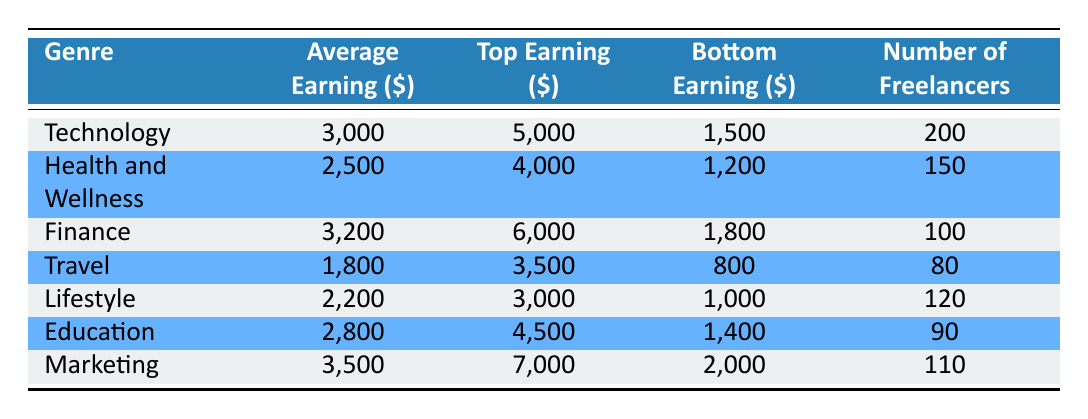What is the average earning for the Marketing genre? The table shows that the average earning for the Marketing genre is listed as 3,500.
Answer: 3,500 Which genre has the highest top earning? By comparing the "Top Earning" column, Marketing has the highest top earning of 7,000, while Finance follows with 6,000.
Answer: Marketing How many freelancers are there in the Travel genre? Referring to the "Number of Freelancers" column, it is stated to be 80 for the Travel genre.
Answer: 80 What is the difference between the average earnings of Technology and Travel genres? The average earning for Technology is 3,000 and for Travel it is 1,800. The difference is 3,000 - 1,800 = 1,200.
Answer: 1,200 Is the bottom earning for the Health and Wellness genre greater than that for the Lifestyle genre? The bottom earning for Health and Wellness is 1,200 and for Lifestyle is 1,000. Since 1,200 is greater than 1,000, the statement is true.
Answer: Yes Which two genres combined have the highest average earning? Looking at the averages, the top two are Marketing (3,500) and Finance (3,200). Their combined average is (3,500 + 3,200) / 2 = 3,350.
Answer: Marketing and Finance What is the total number of freelancers across all genres? Summing the "Number of Freelancers" values across the genres: 200 + 150 + 100 + 80 + 120 + 90 + 110 = 1,050.
Answer: 1,050 Is there any genre with an average earning below 2,000? Looking at the average earnings, the lowest is 1,800 for Travel. So, there is indeed a genre below 2,000.
Answer: Yes What is the average earning of the three genres: Education, Finance, and Health and Wellness? Their average earnings are 2,800 (Education), 3,200 (Finance), and 2,500 (Health and Wellness). Thus, the combined average is (2,800 + 3,200 + 2,500) / 3 = 2,833.33.
Answer: 2,833.33 